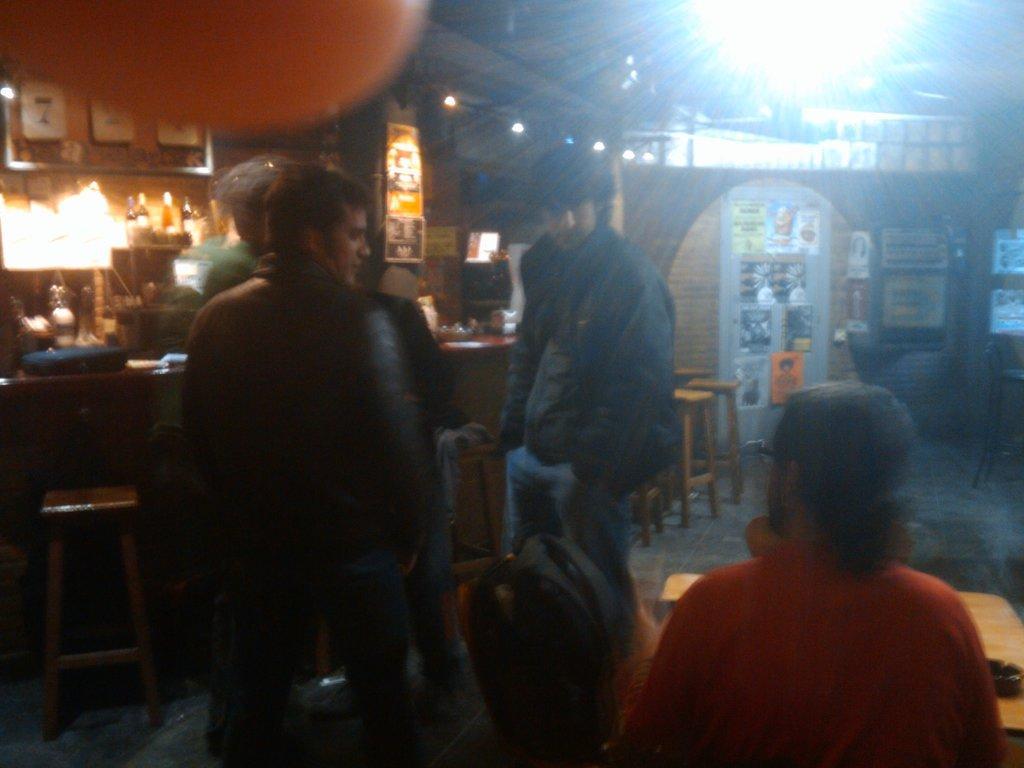Please provide a concise description of this image. In this image i can see a inside view of an building and the right side corner i can see the red color jacket person wearing a cap on his head, on the left side i can see a table ,and i can see a light visible on the left side corner and there are some bottle slept on the left side corner and there are the person standing on the floor on the middle and there are the some tables kept on the right side corner. 